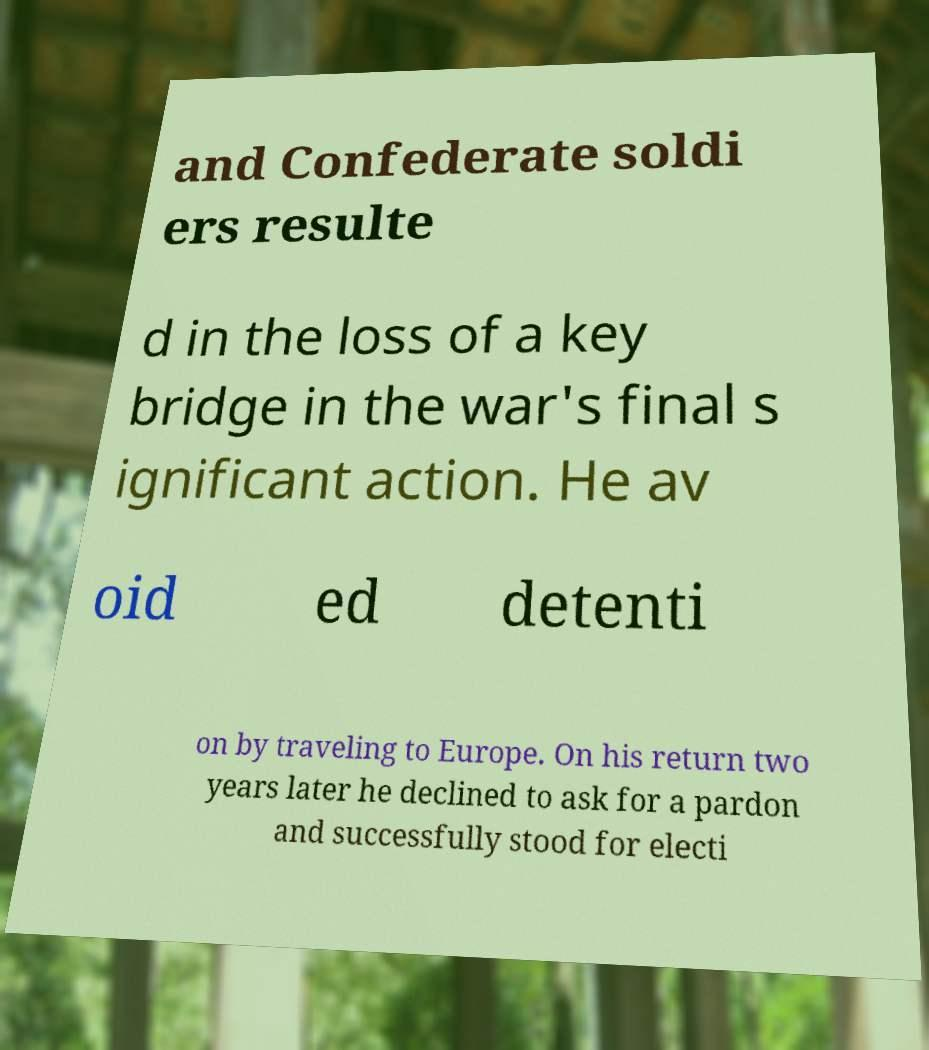For documentation purposes, I need the text within this image transcribed. Could you provide that? and Confederate soldi ers resulte d in the loss of a key bridge in the war's final s ignificant action. He av oid ed detenti on by traveling to Europe. On his return two years later he declined to ask for a pardon and successfully stood for electi 